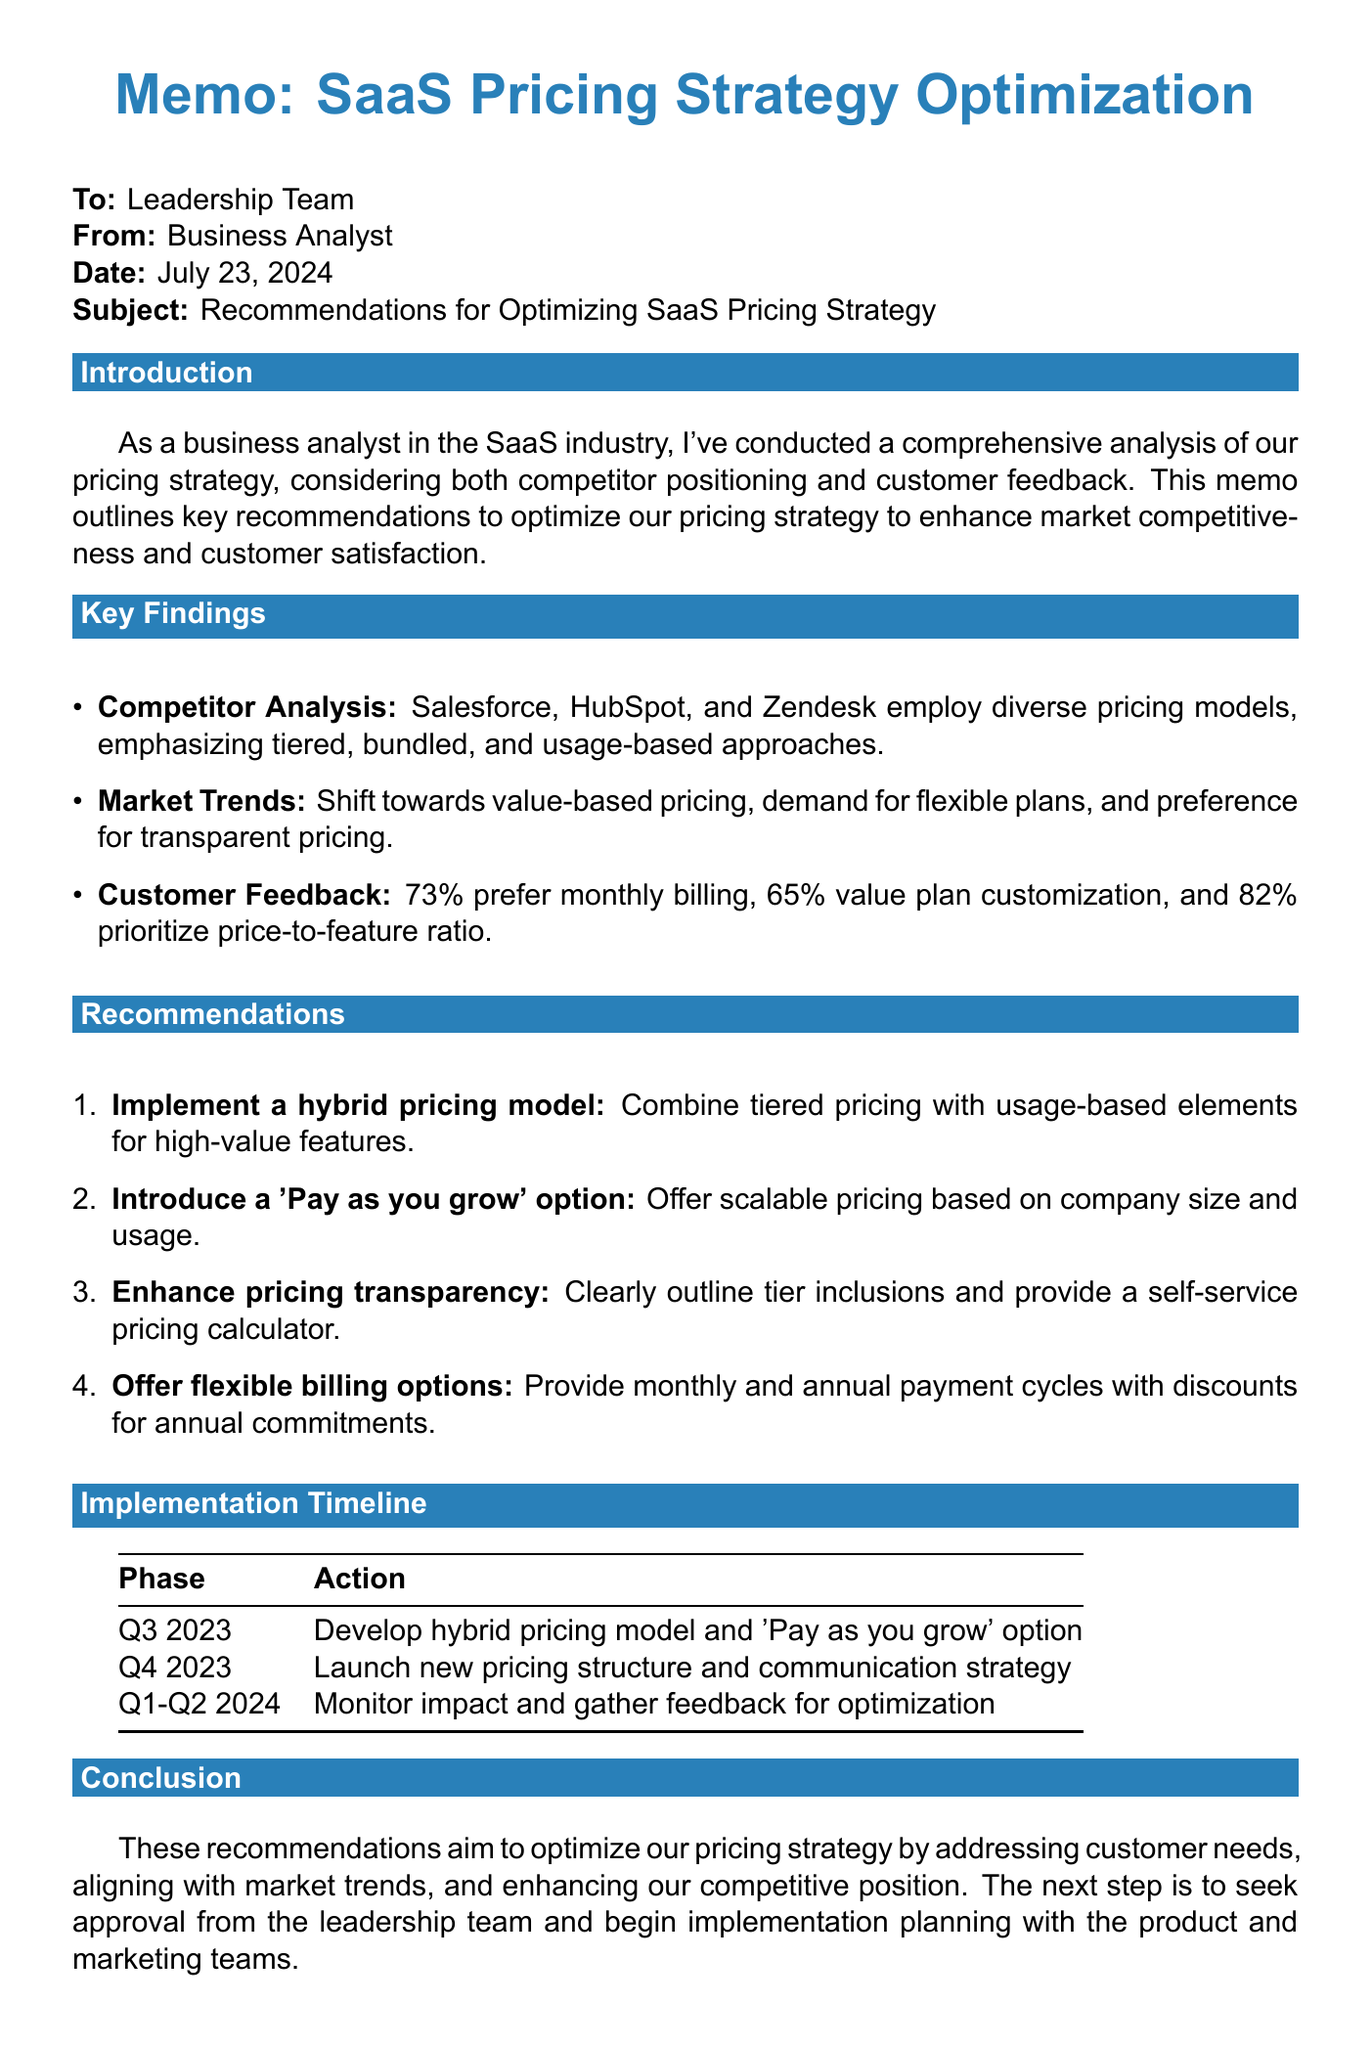what are the key competitors analyzed? The document lists Salesforce, HubSpot, and Zendesk as key competitors in the analysis section.
Answer: Salesforce, HubSpot, Zendesk what percentage of customers prefer monthly billing options? The document states that 73% of customers prefer monthly billing options according to the survey results.
Answer: 73% what pricing model does Zendesk use? The document describes Zendesk's pricing model as usage-based pricing with flexible plans.
Answer: Usage-based pricing with flexible plans what is the rationale for implementing a hybrid pricing model? The rationale for a hybrid pricing model is to address customer desire for customization and align with market trends.
Answer: Addresses customer desire for customization and aligns with market trends what is the timeline for developing the hybrid pricing model? The implementation timeline specifies Q3 2023 for developing the hybrid pricing model and 'Pay as you grow' option.
Answer: Q3 2023 how many customers were surveyed for feedback? The document mentions a sample size of 500 customers who were surveyed for feedback.
Answer: 500 what is one of the market trends identified? The document identifies the shift towards value-based pricing as one of the market trends.
Answer: Shift towards value-based pricing what should the next steps be according to the conclusion? The conclusion suggests seeking approval from the leadership team and beginning implementation planning with product and marketing teams as next steps.
Answer: Seek approval from leadership team and begin implementation planning with the product and marketing teams 